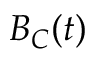Convert formula to latex. <formula><loc_0><loc_0><loc_500><loc_500>B _ { C } ( t )</formula> 